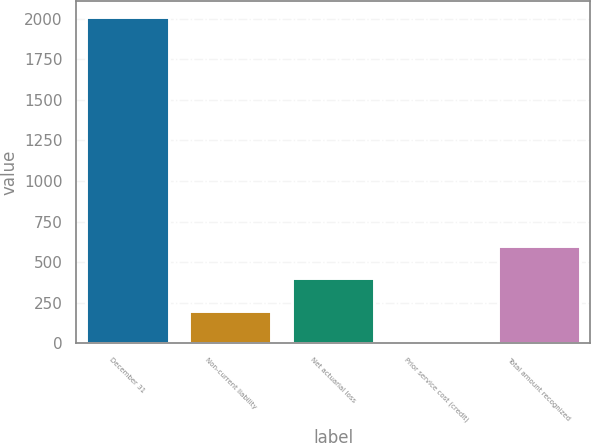<chart> <loc_0><loc_0><loc_500><loc_500><bar_chart><fcel>December 31<fcel>Non-current liability<fcel>Net actuarial loss<fcel>Prior service cost (credit)<fcel>Total amount recognized<nl><fcel>2008<fcel>200.98<fcel>401.76<fcel>0.2<fcel>602.54<nl></chart> 